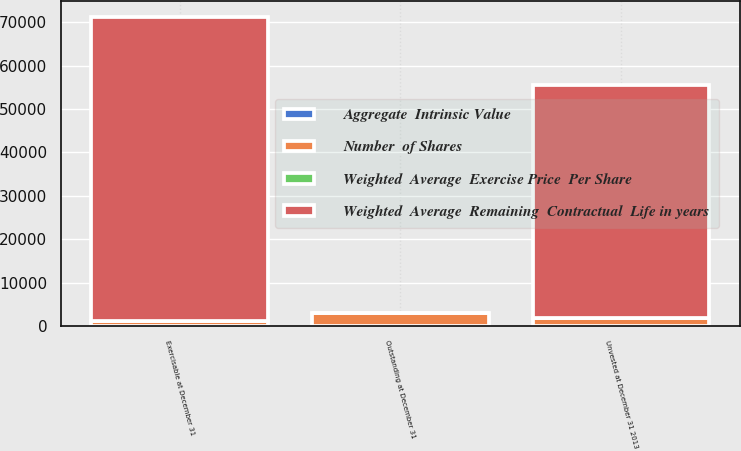<chart> <loc_0><loc_0><loc_500><loc_500><stacked_bar_chart><ecel><fcel>Outstanding at December 31<fcel>Exercisable at December 31<fcel>Unvested at December 31 2013<nl><fcel>Number  of Shares<fcel>2979<fcel>1194<fcel>1785<nl><fcel>Aggregate  Intrinsic Value<fcel>48.3<fcel>31.17<fcel>59.74<nl><fcel>Weighted  Average  Exercise Price  Per Share<fcel>4.3<fcel>2.6<fcel>5.5<nl><fcel>Weighted  Average  Remaining  Contractual  Life in years<fcel>59.74<fcel>70033<fcel>53736<nl></chart> 